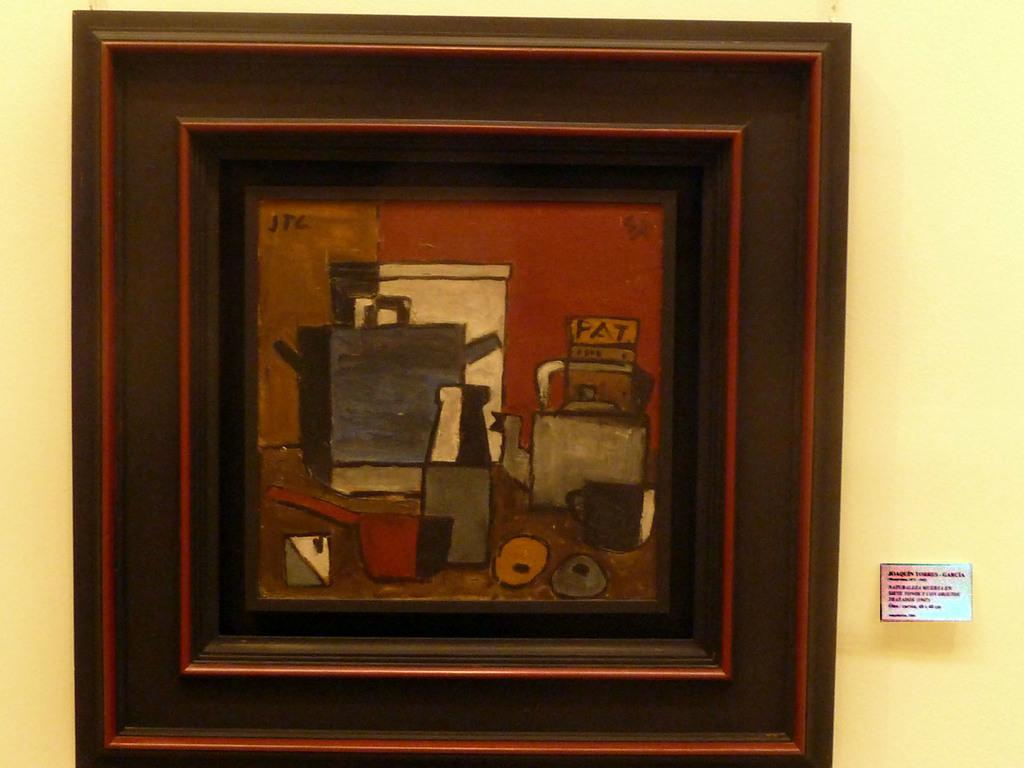What is the main subject in the center of the image? There is a photo frame in the center of the image. Where is the photo frame located? The photo frame is on the wall. What else can be seen on the right side of the image? There is a board on the right side of the image. How many hours does the parent spend with the cows in the image? There are no parents or cows present in the image, so this question cannot be answered. 